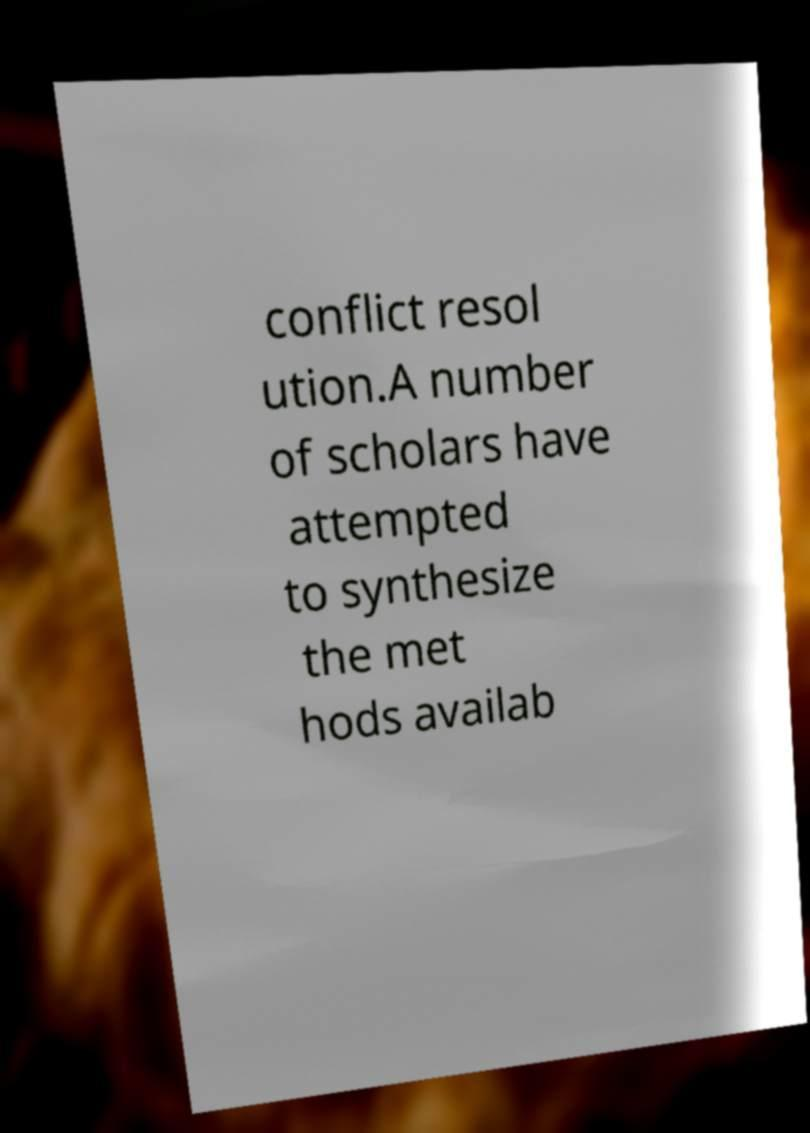Please identify and transcribe the text found in this image. conflict resol ution.A number of scholars have attempted to synthesize the met hods availab 